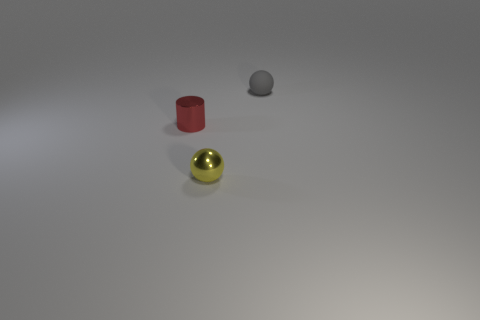What is the color of the tiny metal thing that is the same shape as the small matte object?
Your answer should be very brief. Yellow. Are there any other things that are the same shape as the small red metal thing?
Make the answer very short. No. There is a tiny sphere in front of the matte thing; what is it made of?
Offer a very short reply. Metal. There is another object that is the same shape as the tiny gray rubber object; what is its size?
Ensure brevity in your answer.  Small. What number of cylinders have the same material as the yellow sphere?
Provide a short and direct response. 1. How many other small balls are the same color as the rubber sphere?
Your answer should be compact. 0. What number of objects are either things that are behind the tiny red metal object or tiny balls behind the red metal thing?
Ensure brevity in your answer.  1. Are there fewer yellow objects behind the small yellow shiny ball than tiny gray matte cubes?
Provide a short and direct response. No. Is there a rubber thing that has the same size as the red cylinder?
Your answer should be very brief. Yes. The metal cylinder is what color?
Make the answer very short. Red. 